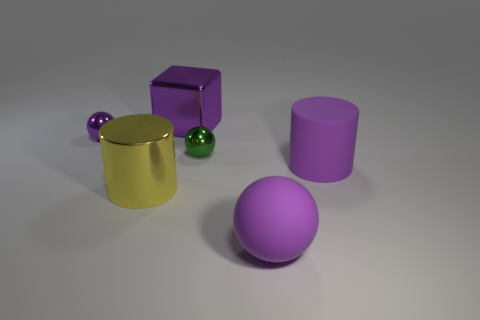Subtract all purple balls. How many were subtracted if there are1purple balls left? 1 Add 2 green objects. How many objects exist? 8 Subtract all cubes. How many objects are left? 5 Subtract 1 green spheres. How many objects are left? 5 Subtract all big purple rubber things. Subtract all big cylinders. How many objects are left? 2 Add 4 large yellow things. How many large yellow things are left? 5 Add 6 big cubes. How many big cubes exist? 7 